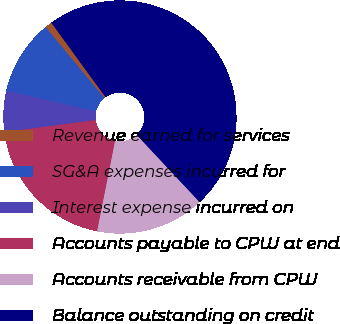Convert chart. <chart><loc_0><loc_0><loc_500><loc_500><pie_chart><fcel>Revenue earned for services<fcel>SG&A expenses incurred for<fcel>Interest expense incurred on<fcel>Accounts payable to CPW at end<fcel>Accounts receivable from CPW<fcel>Balance outstanding on credit<nl><fcel>0.99%<fcel>10.39%<fcel>5.69%<fcel>19.8%<fcel>15.1%<fcel>48.03%<nl></chart> 